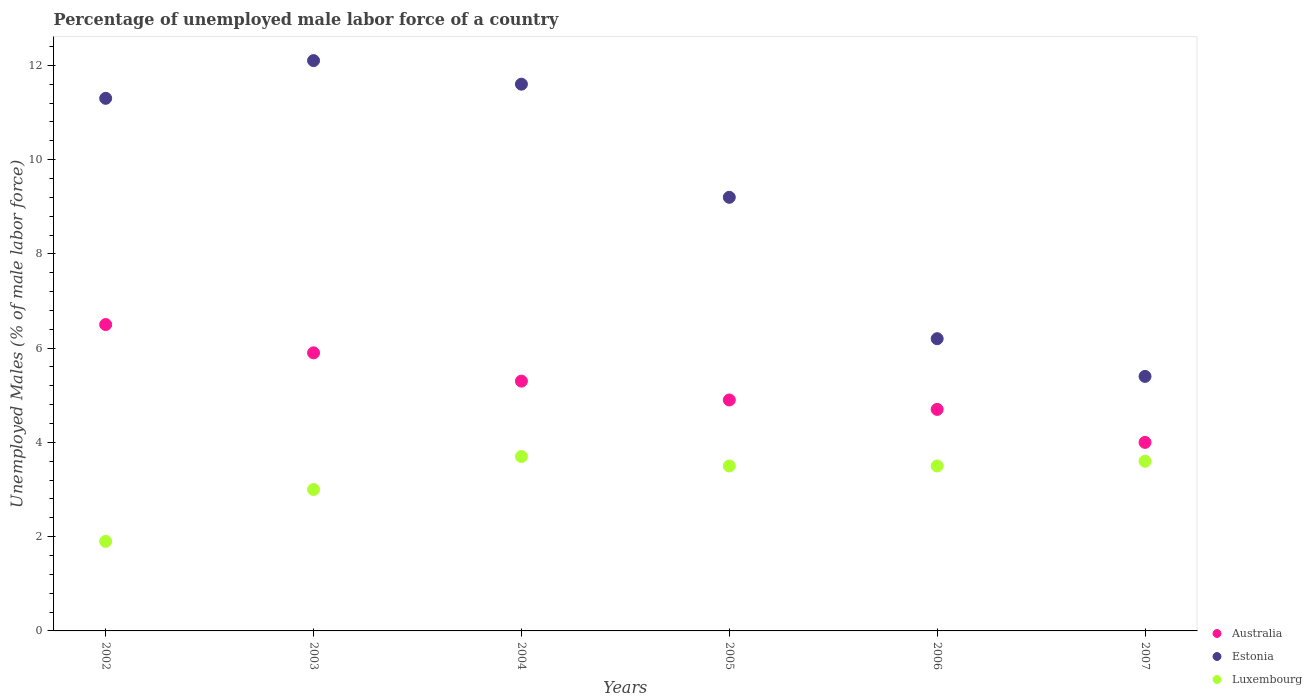Is the number of dotlines equal to the number of legend labels?
Offer a very short reply. Yes. Across all years, what is the maximum percentage of unemployed male labor force in Australia?
Give a very brief answer. 6.5. Across all years, what is the minimum percentage of unemployed male labor force in Estonia?
Provide a succinct answer. 5.4. What is the total percentage of unemployed male labor force in Australia in the graph?
Your answer should be very brief. 31.3. What is the difference between the percentage of unemployed male labor force in Australia in 2002 and that in 2006?
Give a very brief answer. 1.8. What is the difference between the percentage of unemployed male labor force in Luxembourg in 2004 and the percentage of unemployed male labor force in Australia in 2003?
Offer a very short reply. -2.2. What is the average percentage of unemployed male labor force in Australia per year?
Provide a succinct answer. 5.22. In the year 2006, what is the difference between the percentage of unemployed male labor force in Estonia and percentage of unemployed male labor force in Luxembourg?
Offer a terse response. 2.7. What is the ratio of the percentage of unemployed male labor force in Australia in 2002 to that in 2006?
Provide a succinct answer. 1.38. Is the percentage of unemployed male labor force in Australia in 2002 less than that in 2006?
Your answer should be very brief. No. Is the difference between the percentage of unemployed male labor force in Estonia in 2004 and 2005 greater than the difference between the percentage of unemployed male labor force in Luxembourg in 2004 and 2005?
Provide a succinct answer. Yes. What is the difference between the highest and the lowest percentage of unemployed male labor force in Australia?
Your response must be concise. 2.5. Does the percentage of unemployed male labor force in Luxembourg monotonically increase over the years?
Make the answer very short. No. Is the percentage of unemployed male labor force in Luxembourg strictly less than the percentage of unemployed male labor force in Estonia over the years?
Your answer should be very brief. Yes. How many dotlines are there?
Your answer should be very brief. 3. How many years are there in the graph?
Give a very brief answer. 6. What is the difference between two consecutive major ticks on the Y-axis?
Make the answer very short. 2. Does the graph contain any zero values?
Provide a short and direct response. No. Where does the legend appear in the graph?
Your answer should be compact. Bottom right. How many legend labels are there?
Give a very brief answer. 3. What is the title of the graph?
Keep it short and to the point. Percentage of unemployed male labor force of a country. What is the label or title of the Y-axis?
Ensure brevity in your answer.  Unemployed Males (% of male labor force). What is the Unemployed Males (% of male labor force) in Estonia in 2002?
Provide a short and direct response. 11.3. What is the Unemployed Males (% of male labor force) of Luxembourg in 2002?
Ensure brevity in your answer.  1.9. What is the Unemployed Males (% of male labor force) of Australia in 2003?
Your answer should be very brief. 5.9. What is the Unemployed Males (% of male labor force) of Estonia in 2003?
Keep it short and to the point. 12.1. What is the Unemployed Males (% of male labor force) of Australia in 2004?
Give a very brief answer. 5.3. What is the Unemployed Males (% of male labor force) of Estonia in 2004?
Make the answer very short. 11.6. What is the Unemployed Males (% of male labor force) in Luxembourg in 2004?
Keep it short and to the point. 3.7. What is the Unemployed Males (% of male labor force) in Australia in 2005?
Your answer should be very brief. 4.9. What is the Unemployed Males (% of male labor force) of Estonia in 2005?
Your answer should be very brief. 9.2. What is the Unemployed Males (% of male labor force) in Luxembourg in 2005?
Give a very brief answer. 3.5. What is the Unemployed Males (% of male labor force) in Australia in 2006?
Offer a terse response. 4.7. What is the Unemployed Males (% of male labor force) of Estonia in 2006?
Keep it short and to the point. 6.2. What is the Unemployed Males (% of male labor force) in Estonia in 2007?
Keep it short and to the point. 5.4. What is the Unemployed Males (% of male labor force) in Luxembourg in 2007?
Your answer should be very brief. 3.6. Across all years, what is the maximum Unemployed Males (% of male labor force) in Estonia?
Your answer should be very brief. 12.1. Across all years, what is the maximum Unemployed Males (% of male labor force) of Luxembourg?
Your answer should be compact. 3.7. Across all years, what is the minimum Unemployed Males (% of male labor force) of Australia?
Provide a short and direct response. 4. Across all years, what is the minimum Unemployed Males (% of male labor force) of Estonia?
Your response must be concise. 5.4. Across all years, what is the minimum Unemployed Males (% of male labor force) of Luxembourg?
Your answer should be very brief. 1.9. What is the total Unemployed Males (% of male labor force) in Australia in the graph?
Your answer should be compact. 31.3. What is the total Unemployed Males (% of male labor force) in Estonia in the graph?
Offer a terse response. 55.8. What is the difference between the Unemployed Males (% of male labor force) of Australia in 2002 and that in 2003?
Offer a very short reply. 0.6. What is the difference between the Unemployed Males (% of male labor force) in Estonia in 2002 and that in 2003?
Your answer should be very brief. -0.8. What is the difference between the Unemployed Males (% of male labor force) of Australia in 2002 and that in 2005?
Provide a succinct answer. 1.6. What is the difference between the Unemployed Males (% of male labor force) of Luxembourg in 2002 and that in 2005?
Your response must be concise. -1.6. What is the difference between the Unemployed Males (% of male labor force) in Luxembourg in 2002 and that in 2006?
Your answer should be compact. -1.6. What is the difference between the Unemployed Males (% of male labor force) in Australia in 2002 and that in 2007?
Your answer should be compact. 2.5. What is the difference between the Unemployed Males (% of male labor force) in Luxembourg in 2002 and that in 2007?
Keep it short and to the point. -1.7. What is the difference between the Unemployed Males (% of male labor force) in Luxembourg in 2003 and that in 2004?
Your answer should be compact. -0.7. What is the difference between the Unemployed Males (% of male labor force) in Luxembourg in 2003 and that in 2005?
Your answer should be very brief. -0.5. What is the difference between the Unemployed Males (% of male labor force) in Australia in 2003 and that in 2006?
Your answer should be compact. 1.2. What is the difference between the Unemployed Males (% of male labor force) of Estonia in 2003 and that in 2006?
Ensure brevity in your answer.  5.9. What is the difference between the Unemployed Males (% of male labor force) in Luxembourg in 2003 and that in 2006?
Offer a terse response. -0.5. What is the difference between the Unemployed Males (% of male labor force) in Australia in 2003 and that in 2007?
Provide a short and direct response. 1.9. What is the difference between the Unemployed Males (% of male labor force) in Estonia in 2003 and that in 2007?
Keep it short and to the point. 6.7. What is the difference between the Unemployed Males (% of male labor force) of Luxembourg in 2003 and that in 2007?
Ensure brevity in your answer.  -0.6. What is the difference between the Unemployed Males (% of male labor force) in Australia in 2004 and that in 2005?
Your response must be concise. 0.4. What is the difference between the Unemployed Males (% of male labor force) in Estonia in 2004 and that in 2005?
Offer a very short reply. 2.4. What is the difference between the Unemployed Males (% of male labor force) of Luxembourg in 2004 and that in 2005?
Make the answer very short. 0.2. What is the difference between the Unemployed Males (% of male labor force) of Estonia in 2004 and that in 2006?
Keep it short and to the point. 5.4. What is the difference between the Unemployed Males (% of male labor force) of Luxembourg in 2004 and that in 2007?
Provide a succinct answer. 0.1. What is the difference between the Unemployed Males (% of male labor force) in Australia in 2005 and that in 2006?
Keep it short and to the point. 0.2. What is the difference between the Unemployed Males (% of male labor force) in Luxembourg in 2005 and that in 2006?
Your answer should be compact. 0. What is the difference between the Unemployed Males (% of male labor force) in Luxembourg in 2005 and that in 2007?
Provide a short and direct response. -0.1. What is the difference between the Unemployed Males (% of male labor force) in Luxembourg in 2006 and that in 2007?
Keep it short and to the point. -0.1. What is the difference between the Unemployed Males (% of male labor force) in Australia in 2002 and the Unemployed Males (% of male labor force) in Luxembourg in 2003?
Offer a very short reply. 3.5. What is the difference between the Unemployed Males (% of male labor force) in Australia in 2002 and the Unemployed Males (% of male labor force) in Luxembourg in 2004?
Your answer should be very brief. 2.8. What is the difference between the Unemployed Males (% of male labor force) of Australia in 2002 and the Unemployed Males (% of male labor force) of Luxembourg in 2005?
Your response must be concise. 3. What is the difference between the Unemployed Males (% of male labor force) of Australia in 2002 and the Unemployed Males (% of male labor force) of Estonia in 2006?
Ensure brevity in your answer.  0.3. What is the difference between the Unemployed Males (% of male labor force) in Australia in 2003 and the Unemployed Males (% of male labor force) in Luxembourg in 2005?
Keep it short and to the point. 2.4. What is the difference between the Unemployed Males (% of male labor force) of Estonia in 2003 and the Unemployed Males (% of male labor force) of Luxembourg in 2005?
Ensure brevity in your answer.  8.6. What is the difference between the Unemployed Males (% of male labor force) in Australia in 2003 and the Unemployed Males (% of male labor force) in Estonia in 2006?
Ensure brevity in your answer.  -0.3. What is the difference between the Unemployed Males (% of male labor force) of Estonia in 2003 and the Unemployed Males (% of male labor force) of Luxembourg in 2006?
Offer a terse response. 8.6. What is the difference between the Unemployed Males (% of male labor force) in Australia in 2003 and the Unemployed Males (% of male labor force) in Luxembourg in 2007?
Provide a succinct answer. 2.3. What is the difference between the Unemployed Males (% of male labor force) of Australia in 2004 and the Unemployed Males (% of male labor force) of Estonia in 2005?
Your response must be concise. -3.9. What is the difference between the Unemployed Males (% of male labor force) in Australia in 2004 and the Unemployed Males (% of male labor force) in Luxembourg in 2006?
Keep it short and to the point. 1.8. What is the difference between the Unemployed Males (% of male labor force) of Estonia in 2004 and the Unemployed Males (% of male labor force) of Luxembourg in 2006?
Offer a terse response. 8.1. What is the difference between the Unemployed Males (% of male labor force) in Australia in 2004 and the Unemployed Males (% of male labor force) in Estonia in 2007?
Offer a very short reply. -0.1. What is the difference between the Unemployed Males (% of male labor force) of Estonia in 2004 and the Unemployed Males (% of male labor force) of Luxembourg in 2007?
Keep it short and to the point. 8. What is the difference between the Unemployed Males (% of male labor force) in Australia in 2005 and the Unemployed Males (% of male labor force) in Estonia in 2006?
Offer a terse response. -1.3. What is the difference between the Unemployed Males (% of male labor force) in Australia in 2005 and the Unemployed Males (% of male labor force) in Luxembourg in 2006?
Provide a succinct answer. 1.4. What is the difference between the Unemployed Males (% of male labor force) of Australia in 2005 and the Unemployed Males (% of male labor force) of Luxembourg in 2007?
Provide a short and direct response. 1.3. What is the difference between the Unemployed Males (% of male labor force) of Estonia in 2005 and the Unemployed Males (% of male labor force) of Luxembourg in 2007?
Offer a very short reply. 5.6. What is the difference between the Unemployed Males (% of male labor force) in Australia in 2006 and the Unemployed Males (% of male labor force) in Luxembourg in 2007?
Offer a very short reply. 1.1. What is the difference between the Unemployed Males (% of male labor force) of Estonia in 2006 and the Unemployed Males (% of male labor force) of Luxembourg in 2007?
Provide a short and direct response. 2.6. What is the average Unemployed Males (% of male labor force) in Australia per year?
Offer a terse response. 5.22. What is the average Unemployed Males (% of male labor force) of Estonia per year?
Your response must be concise. 9.3. In the year 2002, what is the difference between the Unemployed Males (% of male labor force) of Australia and Unemployed Males (% of male labor force) of Luxembourg?
Provide a succinct answer. 4.6. In the year 2003, what is the difference between the Unemployed Males (% of male labor force) of Australia and Unemployed Males (% of male labor force) of Luxembourg?
Your answer should be compact. 2.9. In the year 2005, what is the difference between the Unemployed Males (% of male labor force) in Australia and Unemployed Males (% of male labor force) in Luxembourg?
Your answer should be compact. 1.4. In the year 2006, what is the difference between the Unemployed Males (% of male labor force) in Australia and Unemployed Males (% of male labor force) in Estonia?
Your answer should be compact. -1.5. In the year 2007, what is the difference between the Unemployed Males (% of male labor force) in Australia and Unemployed Males (% of male labor force) in Estonia?
Provide a succinct answer. -1.4. In the year 2007, what is the difference between the Unemployed Males (% of male labor force) in Estonia and Unemployed Males (% of male labor force) in Luxembourg?
Offer a terse response. 1.8. What is the ratio of the Unemployed Males (% of male labor force) of Australia in 2002 to that in 2003?
Provide a succinct answer. 1.1. What is the ratio of the Unemployed Males (% of male labor force) in Estonia in 2002 to that in 2003?
Keep it short and to the point. 0.93. What is the ratio of the Unemployed Males (% of male labor force) of Luxembourg in 2002 to that in 2003?
Your answer should be very brief. 0.63. What is the ratio of the Unemployed Males (% of male labor force) in Australia in 2002 to that in 2004?
Make the answer very short. 1.23. What is the ratio of the Unemployed Males (% of male labor force) of Estonia in 2002 to that in 2004?
Your answer should be compact. 0.97. What is the ratio of the Unemployed Males (% of male labor force) of Luxembourg in 2002 to that in 2004?
Keep it short and to the point. 0.51. What is the ratio of the Unemployed Males (% of male labor force) of Australia in 2002 to that in 2005?
Give a very brief answer. 1.33. What is the ratio of the Unemployed Males (% of male labor force) of Estonia in 2002 to that in 2005?
Offer a very short reply. 1.23. What is the ratio of the Unemployed Males (% of male labor force) in Luxembourg in 2002 to that in 2005?
Make the answer very short. 0.54. What is the ratio of the Unemployed Males (% of male labor force) of Australia in 2002 to that in 2006?
Offer a terse response. 1.38. What is the ratio of the Unemployed Males (% of male labor force) in Estonia in 2002 to that in 2006?
Offer a very short reply. 1.82. What is the ratio of the Unemployed Males (% of male labor force) in Luxembourg in 2002 to that in 2006?
Give a very brief answer. 0.54. What is the ratio of the Unemployed Males (% of male labor force) of Australia in 2002 to that in 2007?
Give a very brief answer. 1.62. What is the ratio of the Unemployed Males (% of male labor force) of Estonia in 2002 to that in 2007?
Keep it short and to the point. 2.09. What is the ratio of the Unemployed Males (% of male labor force) of Luxembourg in 2002 to that in 2007?
Offer a terse response. 0.53. What is the ratio of the Unemployed Males (% of male labor force) in Australia in 2003 to that in 2004?
Provide a succinct answer. 1.11. What is the ratio of the Unemployed Males (% of male labor force) in Estonia in 2003 to that in 2004?
Ensure brevity in your answer.  1.04. What is the ratio of the Unemployed Males (% of male labor force) in Luxembourg in 2003 to that in 2004?
Give a very brief answer. 0.81. What is the ratio of the Unemployed Males (% of male labor force) of Australia in 2003 to that in 2005?
Provide a succinct answer. 1.2. What is the ratio of the Unemployed Males (% of male labor force) of Estonia in 2003 to that in 2005?
Make the answer very short. 1.32. What is the ratio of the Unemployed Males (% of male labor force) in Australia in 2003 to that in 2006?
Offer a terse response. 1.26. What is the ratio of the Unemployed Males (% of male labor force) in Estonia in 2003 to that in 2006?
Provide a short and direct response. 1.95. What is the ratio of the Unemployed Males (% of male labor force) in Australia in 2003 to that in 2007?
Provide a succinct answer. 1.48. What is the ratio of the Unemployed Males (% of male labor force) in Estonia in 2003 to that in 2007?
Your answer should be very brief. 2.24. What is the ratio of the Unemployed Males (% of male labor force) in Australia in 2004 to that in 2005?
Offer a terse response. 1.08. What is the ratio of the Unemployed Males (% of male labor force) of Estonia in 2004 to that in 2005?
Provide a succinct answer. 1.26. What is the ratio of the Unemployed Males (% of male labor force) of Luxembourg in 2004 to that in 2005?
Provide a succinct answer. 1.06. What is the ratio of the Unemployed Males (% of male labor force) in Australia in 2004 to that in 2006?
Provide a succinct answer. 1.13. What is the ratio of the Unemployed Males (% of male labor force) in Estonia in 2004 to that in 2006?
Your response must be concise. 1.87. What is the ratio of the Unemployed Males (% of male labor force) of Luxembourg in 2004 to that in 2006?
Your response must be concise. 1.06. What is the ratio of the Unemployed Males (% of male labor force) in Australia in 2004 to that in 2007?
Your response must be concise. 1.32. What is the ratio of the Unemployed Males (% of male labor force) of Estonia in 2004 to that in 2007?
Your answer should be compact. 2.15. What is the ratio of the Unemployed Males (% of male labor force) of Luxembourg in 2004 to that in 2007?
Your answer should be very brief. 1.03. What is the ratio of the Unemployed Males (% of male labor force) of Australia in 2005 to that in 2006?
Your answer should be compact. 1.04. What is the ratio of the Unemployed Males (% of male labor force) of Estonia in 2005 to that in 2006?
Give a very brief answer. 1.48. What is the ratio of the Unemployed Males (% of male labor force) in Australia in 2005 to that in 2007?
Ensure brevity in your answer.  1.23. What is the ratio of the Unemployed Males (% of male labor force) of Estonia in 2005 to that in 2007?
Provide a short and direct response. 1.7. What is the ratio of the Unemployed Males (% of male labor force) of Luxembourg in 2005 to that in 2007?
Make the answer very short. 0.97. What is the ratio of the Unemployed Males (% of male labor force) in Australia in 2006 to that in 2007?
Keep it short and to the point. 1.18. What is the ratio of the Unemployed Males (% of male labor force) of Estonia in 2006 to that in 2007?
Offer a terse response. 1.15. What is the ratio of the Unemployed Males (% of male labor force) of Luxembourg in 2006 to that in 2007?
Your answer should be compact. 0.97. What is the difference between the highest and the second highest Unemployed Males (% of male labor force) in Estonia?
Provide a short and direct response. 0.5. What is the difference between the highest and the second highest Unemployed Males (% of male labor force) of Luxembourg?
Offer a very short reply. 0.1. What is the difference between the highest and the lowest Unemployed Males (% of male labor force) of Estonia?
Keep it short and to the point. 6.7. 